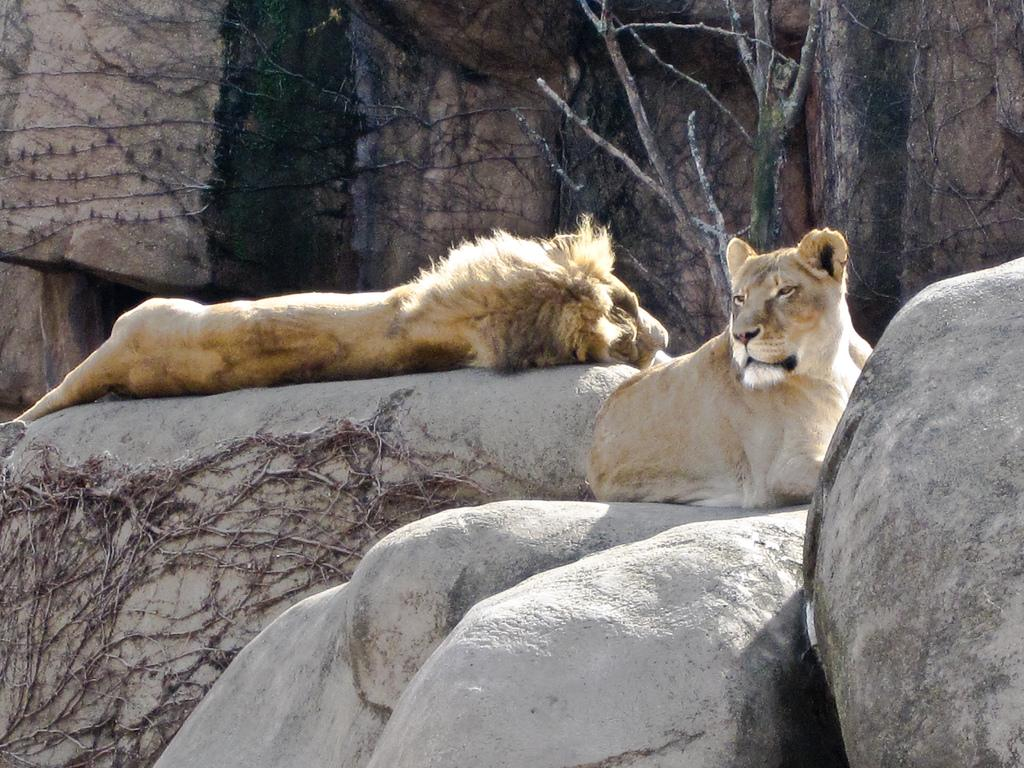What animal can be seen lying on a rock in the image? There is a lion lying on a rock in the image. What other lion can be seen in the image? There is a lioness sitting in the image. When was the image taken? The image was taken during the day. What type of landscape is visible in the background of the image? There are mountains visible in the background of the image. What type of spoon is the lion using to eat in the image? There is no spoon present in the image, and the lion is not eating. What list is the lioness holding in the image? There is no list present in the image, and the lioness is not holding anything. 